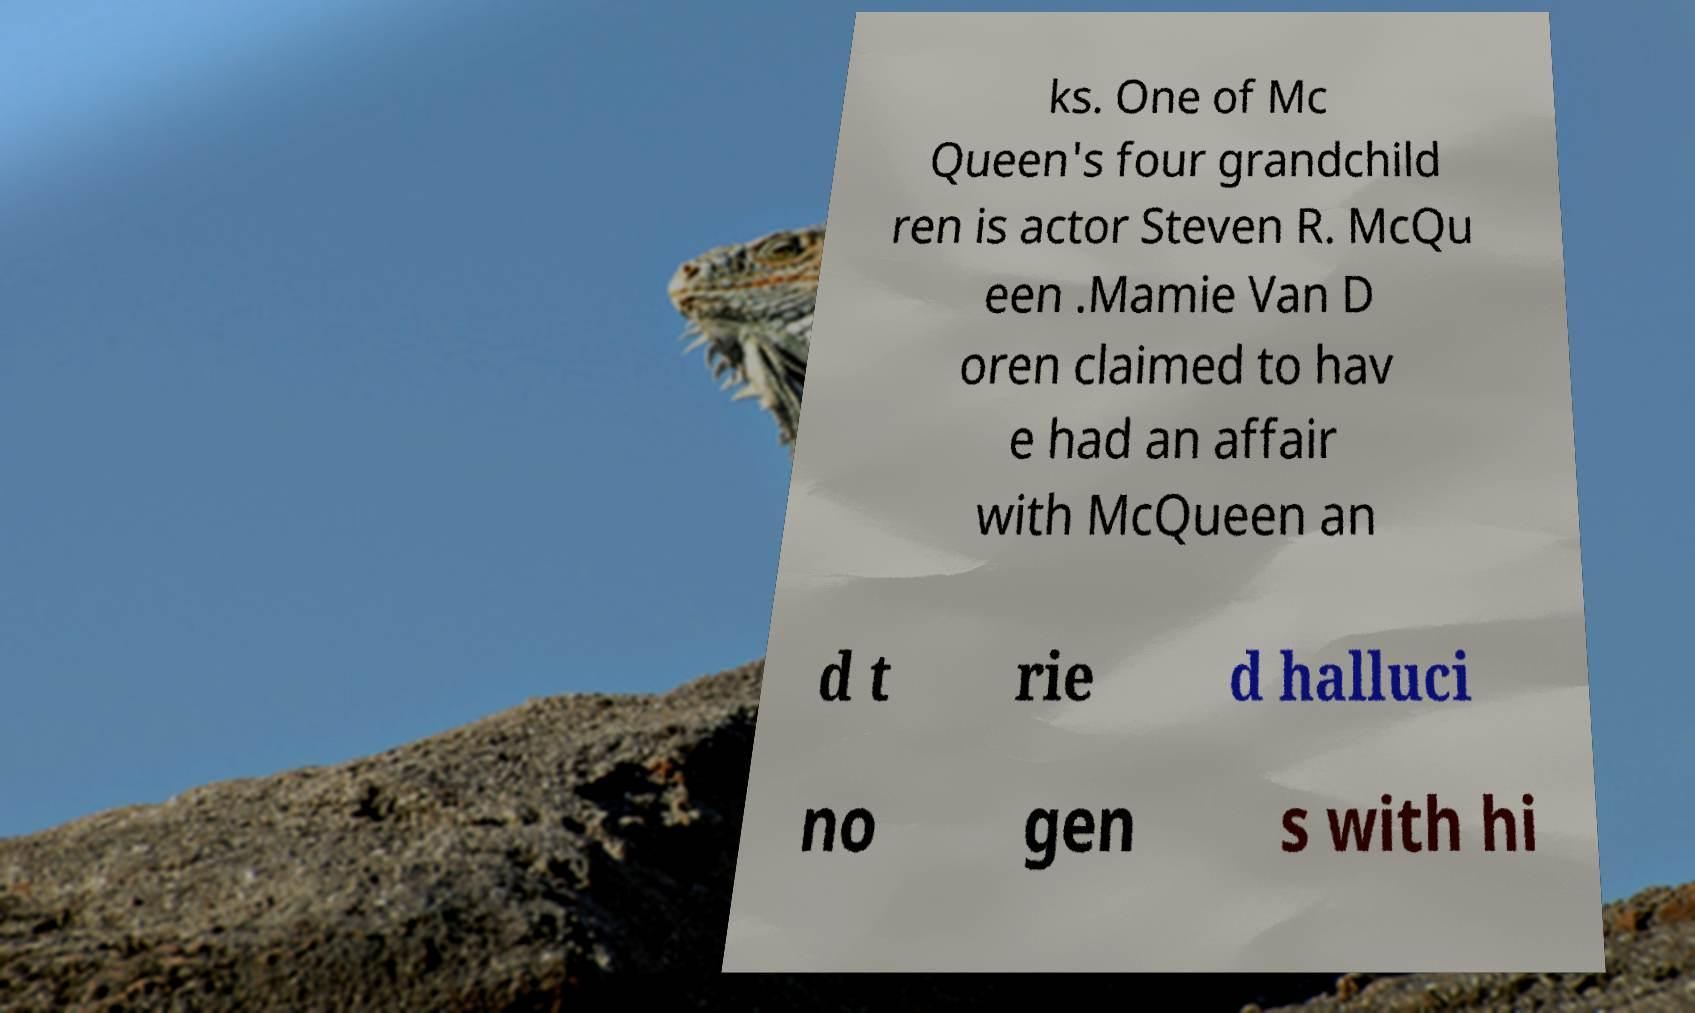For documentation purposes, I need the text within this image transcribed. Could you provide that? ks. One of Mc Queen's four grandchild ren is actor Steven R. McQu een .Mamie Van D oren claimed to hav e had an affair with McQueen an d t rie d halluci no gen s with hi 